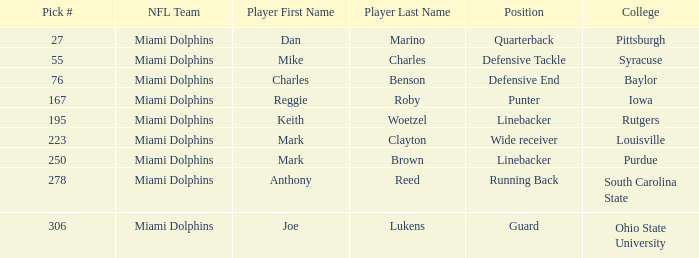If the Position is Running Back what is the Total number of Pick #? 1.0. 